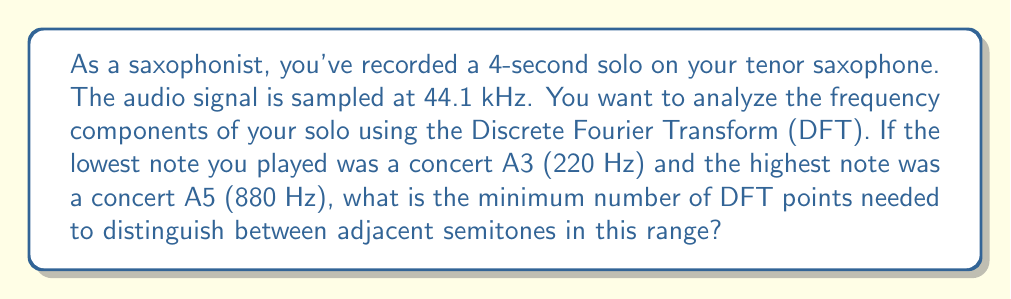Provide a solution to this math problem. To solve this problem, we need to follow these steps:

1) First, let's calculate the frequency resolution we need. The smallest interval between two adjacent semitones is approximately 6% of the lower frequency. For A3 (220 Hz), this is:

   $\Delta f = 220 \text{ Hz} \times 0.06 \approx 13.2 \text{ Hz}$

2) The frequency resolution of a DFT is given by:

   $\Delta f = \frac{f_s}{N}$

   where $f_s$ is the sampling frequency and $N$ is the number of DFT points.

3) We can rearrange this to solve for $N$:

   $N = \frac{f_s}{\Delta f}$

4) Substituting our values:

   $N = \frac{44100 \text{ Hz}}{13.2 \text{ Hz}} \approx 3340.9$

5) Since $N$ must be an integer, we round up to the next whole number:

   $N = 3341$

6) However, it's common practice to use a power of 2 for the number of DFT points for computational efficiency. The next power of 2 above 3341 is 4096.

Therefore, the minimum number of DFT points needed is 4096.

Note: This will actually give us better frequency resolution than strictly necessary, but it's a common practice in signal processing to use powers of 2 for FFT algorithms.
Answer: 4096 points 